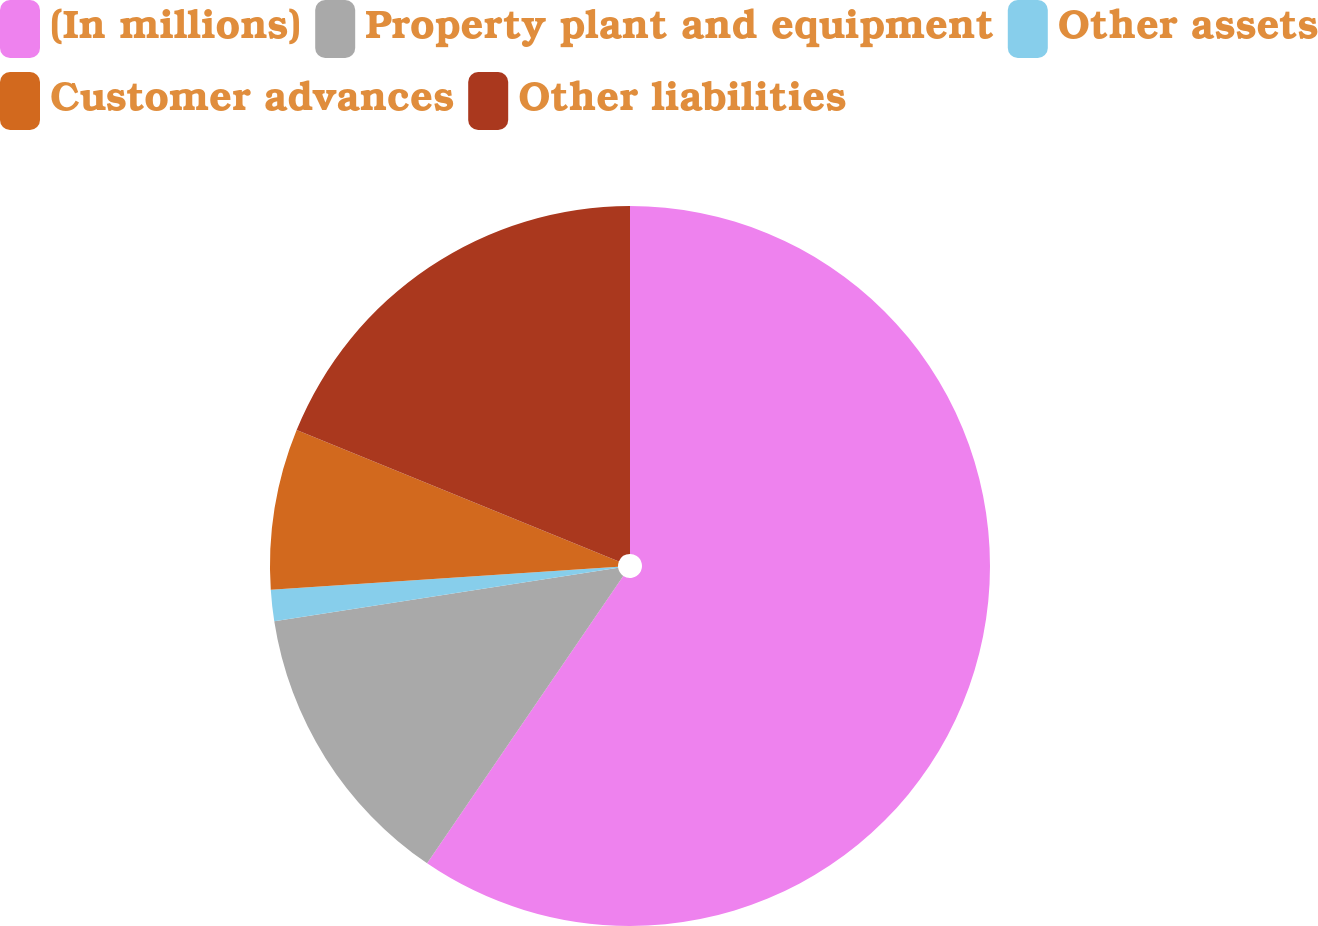Convert chart to OTSL. <chart><loc_0><loc_0><loc_500><loc_500><pie_chart><fcel>(In millions)<fcel>Property plant and equipment<fcel>Other assets<fcel>Customer advances<fcel>Other liabilities<nl><fcel>59.53%<fcel>13.02%<fcel>1.4%<fcel>7.21%<fcel>18.84%<nl></chart> 